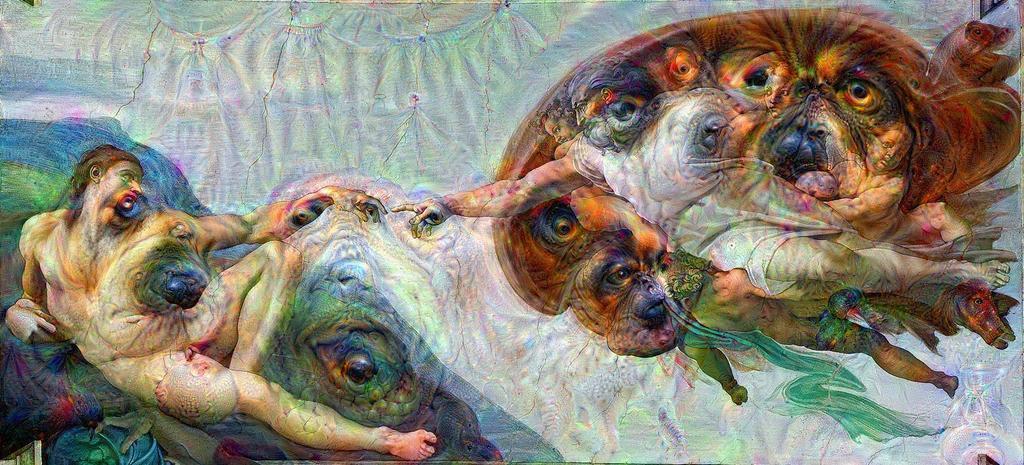In one or two sentences, can you explain what this image depicts? This is the picture of a painting in which there are some dogs and some people. 